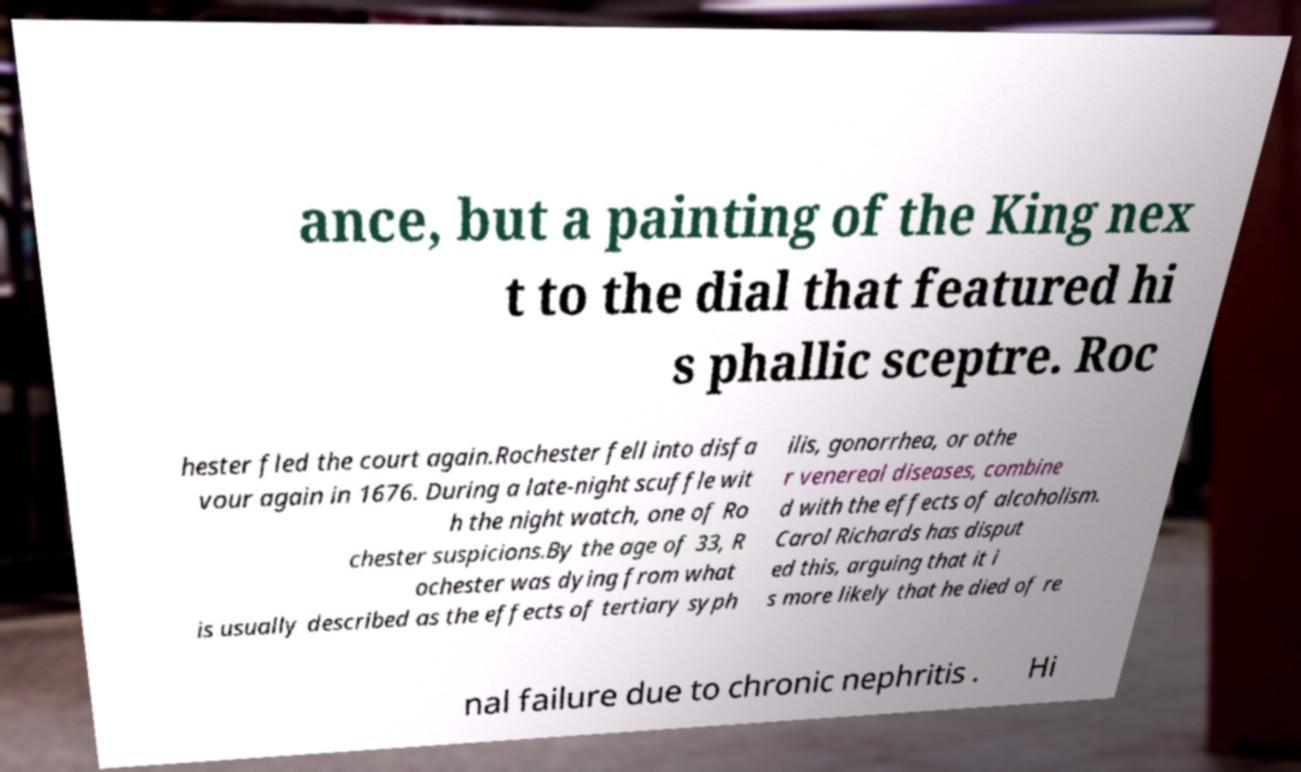For documentation purposes, I need the text within this image transcribed. Could you provide that? ance, but a painting of the King nex t to the dial that featured hi s phallic sceptre. Roc hester fled the court again.Rochester fell into disfa vour again in 1676. During a late-night scuffle wit h the night watch, one of Ro chester suspicions.By the age of 33, R ochester was dying from what is usually described as the effects of tertiary syph ilis, gonorrhea, or othe r venereal diseases, combine d with the effects of alcoholism. Carol Richards has disput ed this, arguing that it i s more likely that he died of re nal failure due to chronic nephritis . Hi 